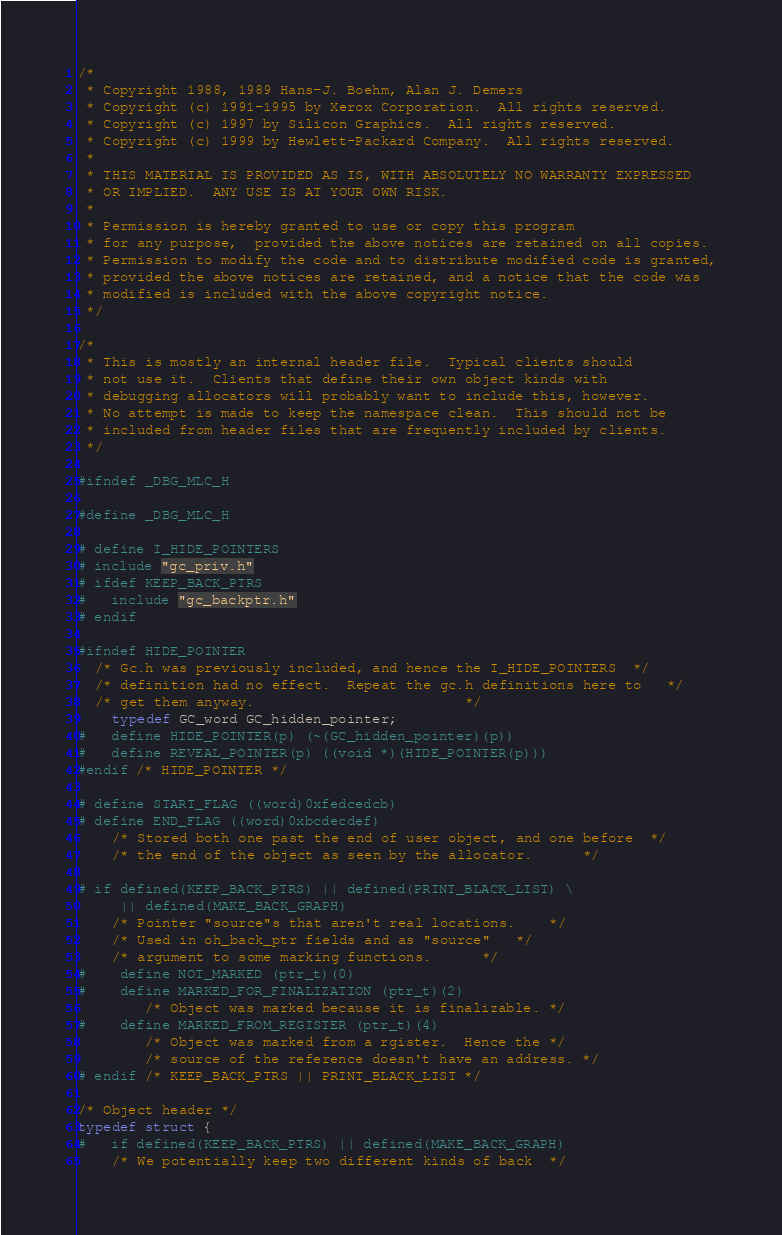<code> <loc_0><loc_0><loc_500><loc_500><_C_>/* 
 * Copyright 1988, 1989 Hans-J. Boehm, Alan J. Demers
 * Copyright (c) 1991-1995 by Xerox Corporation.  All rights reserved.
 * Copyright (c) 1997 by Silicon Graphics.  All rights reserved.
 * Copyright (c) 1999 by Hewlett-Packard Company.  All rights reserved.
 *
 * THIS MATERIAL IS PROVIDED AS IS, WITH ABSOLUTELY NO WARRANTY EXPRESSED
 * OR IMPLIED.  ANY USE IS AT YOUR OWN RISK.
 *
 * Permission is hereby granted to use or copy this program
 * for any purpose,  provided the above notices are retained on all copies.
 * Permission to modify the code and to distribute modified code is granted,
 * provided the above notices are retained, and a notice that the code was
 * modified is included with the above copyright notice.
 */

/*
 * This is mostly an internal header file.  Typical clients should
 * not use it.  Clients that define their own object kinds with
 * debugging allocators will probably want to include this, however.
 * No attempt is made to keep the namespace clean.  This should not be
 * included from header files that are frequently included by clients.
 */

#ifndef _DBG_MLC_H

#define _DBG_MLC_H

# define I_HIDE_POINTERS
# include "gc_priv.h"
# ifdef KEEP_BACK_PTRS
#   include "gc_backptr.h"
# endif

#ifndef HIDE_POINTER
  /* Gc.h was previously included, and hence the I_HIDE_POINTERS	*/
  /* definition had no effect.  Repeat the gc.h definitions here to	*/
  /* get them anyway.							*/
    typedef GC_word GC_hidden_pointer;
#   define HIDE_POINTER(p) (~(GC_hidden_pointer)(p))
#   define REVEAL_POINTER(p) ((void *)(HIDE_POINTER(p)))
#endif /* HIDE_POINTER */

# define START_FLAG ((word)0xfedcedcb)
# define END_FLAG ((word)0xbcdecdef)
	/* Stored both one past the end of user object, and one before	*/
	/* the end of the object as seen by the allocator.		*/

# if defined(KEEP_BACK_PTRS) || defined(PRINT_BLACK_LIST) \
     || defined(MAKE_BACK_GRAPH)
    /* Pointer "source"s that aren't real locations.	*/
    /* Used in oh_back_ptr fields and as "source"	*/
    /* argument to some marking functions.		*/
#	define NOT_MARKED (ptr_t)(0)
#	define MARKED_FOR_FINALIZATION (ptr_t)(2)
	    /* Object was marked because it is finalizable.	*/
#	define MARKED_FROM_REGISTER (ptr_t)(4)
	    /* Object was marked from a rgister.  Hence the	*/
	    /* source of the reference doesn't have an address.	*/
# endif /* KEEP_BACK_PTRS || PRINT_BLACK_LIST */

/* Object header */
typedef struct {
#   if defined(KEEP_BACK_PTRS) || defined(MAKE_BACK_GRAPH)
	/* We potentially keep two different kinds of back 	*/</code> 